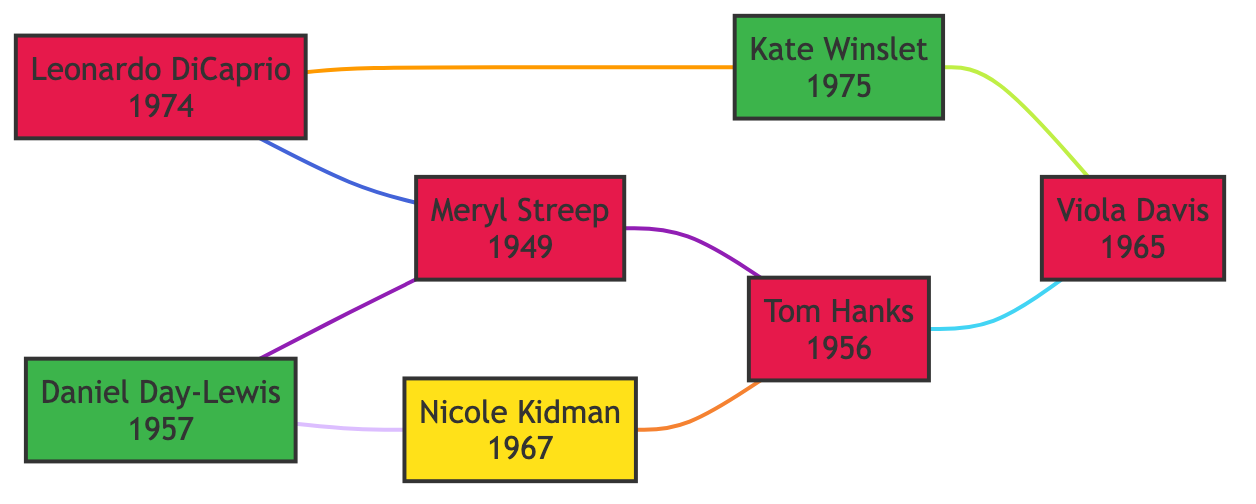What year was "Titanic" released? The edge connecting Leonardo DiCaprio and Kate Winslet has the label "Titanic" with the year 1997 noted beside it. Therefore, looking at this edge provides the release year.
Answer: 1997 Who co-starred with Meryl Streep in "The Post"? The edge connecting Meryl Streep and Tom Hanks is labeled with the film "The Post." This means Tom Hanks is the co-star.
Answer: Tom Hanks How many edges are connected to Tom Hanks? Counting the edges connected to Tom Hanks in the diagram, we see he has four connections: to Meryl Streep, Viola Davis, Leonardo DiCaprio, and Nicole Kidman. This involves iterating through each edge starting from Tom Hanks.
Answer: 4 Which actress acted with Leonardo DiCaprio in two different films? The edges connected to Leonardo DiCaprio show connections to Kate Winslet and Meryl Streep; however, Kate Winslet is noted in both "Titanic" and as being connected to Viola Davis in "Fences," which makes her the only actress with multiple film connections.
Answer: Kate Winslet What nationality is Viola Davis? Referring to the node representing Viola Davis, the nationality specified is "American," as is noted in her node description.
Answer: American Which two actors are connected by the film "Nine"? Looking at the edges, the connection labeled "Nine" is between Daniel Day-Lewis and Nicole Kidman, indicating their collaboration in this film.
Answer: Daniel Day-Lewis and Nicole Kidman What is the total number of unique actors in the diagram? By counting each distinct node in the diagram, we see that there are seven unique actors: Leonardo DiCaprio, Kate Winslet, Meryl Streep, Tom Hanks, Nicole Kidman, Daniel Day-Lewis, and Viola Davis.
Answer: 7 Which film connects Daniel Day-Lewis and Meryl Streep? The edge linking Daniel Day-Lewis and Meryl Streep is marked with "The Post," which identifies this film as their collaborative project.
Answer: The Post Who is the oldest actor in the diagram? Checking the birth years listed for each actor, Meryl Streep has the earliest birth year of 1949, making her the oldest among the actors in the diagram.
Answer: Meryl Streep 